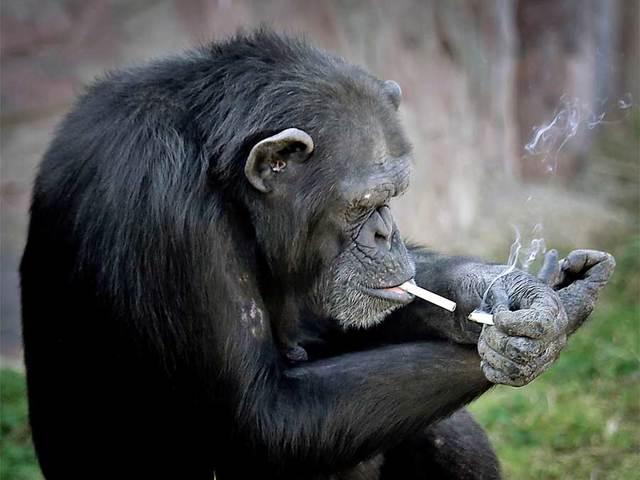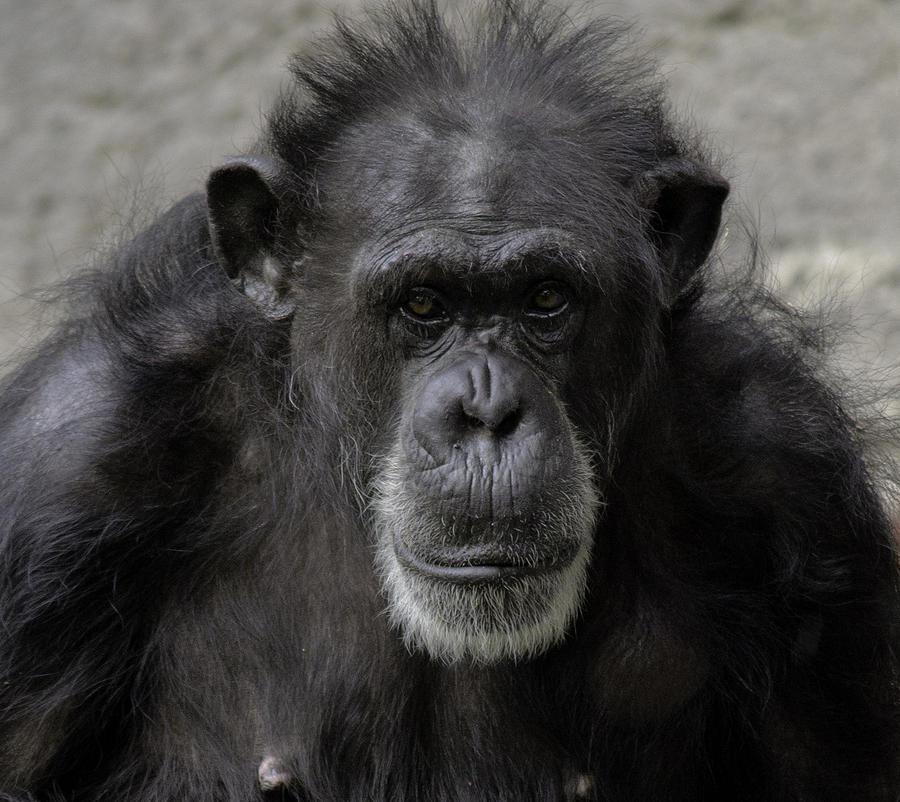The first image is the image on the left, the second image is the image on the right. Analyze the images presented: Is the assertion "At least one of the primates is smoking." valid? Answer yes or no. Yes. 